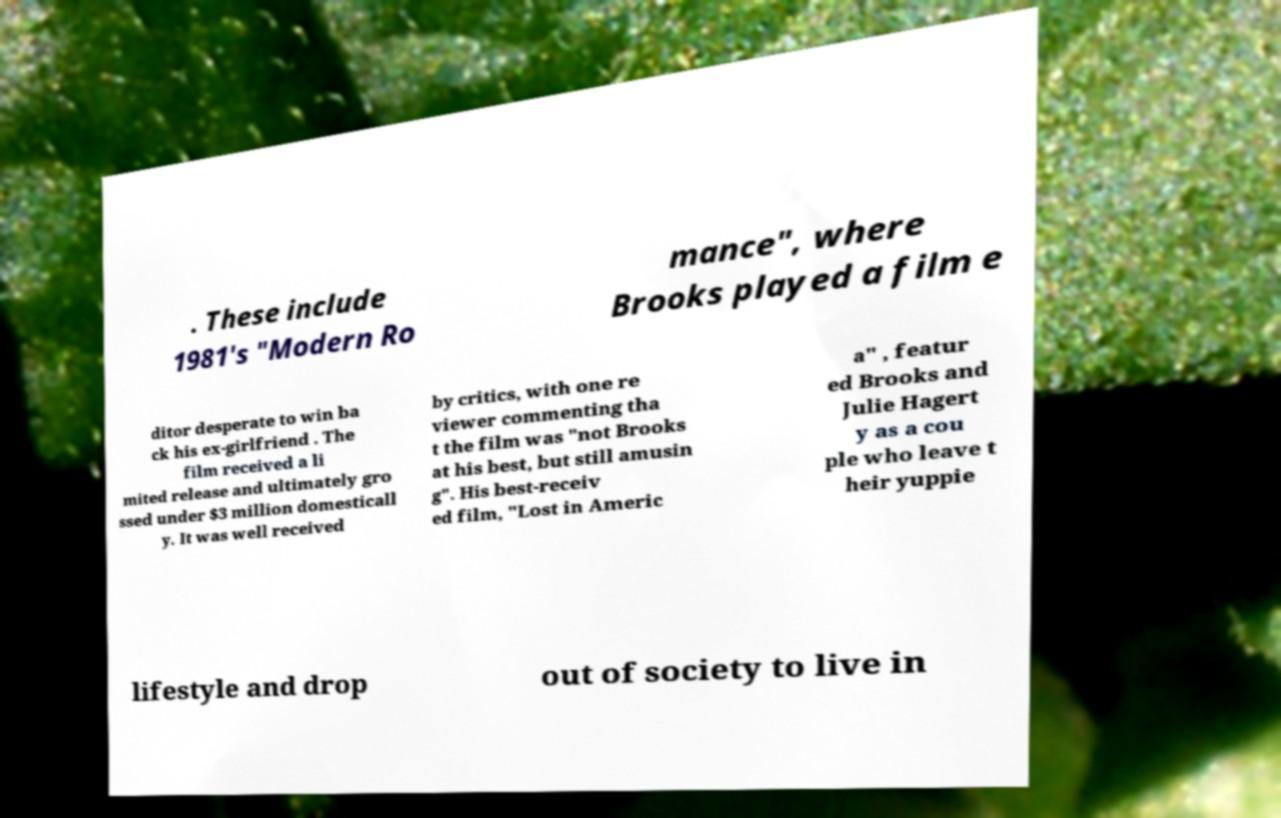For documentation purposes, I need the text within this image transcribed. Could you provide that? . These include 1981's "Modern Ro mance", where Brooks played a film e ditor desperate to win ba ck his ex-girlfriend . The film received a li mited release and ultimately gro ssed under $3 million domesticall y. It was well received by critics, with one re viewer commenting tha t the film was "not Brooks at his best, but still amusin g". His best-receiv ed film, "Lost in Americ a" , featur ed Brooks and Julie Hagert y as a cou ple who leave t heir yuppie lifestyle and drop out of society to live in 